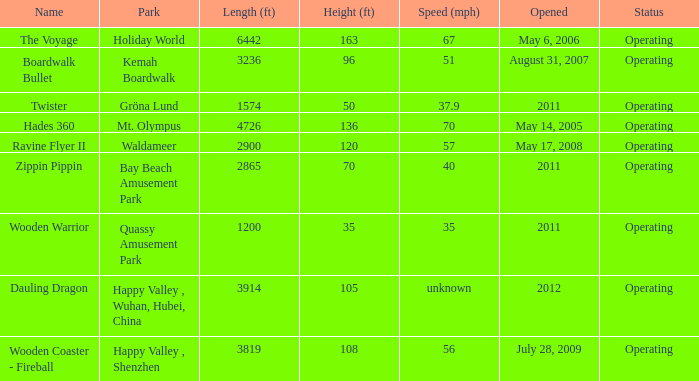How many parks is Zippin Pippin located in 1.0. Give me the full table as a dictionary. {'header': ['Name', 'Park', 'Length (ft)', 'Height (ft)', 'Speed (mph)', 'Opened', 'Status'], 'rows': [['The Voyage', 'Holiday World', '6442', '163', '67', 'May 6, 2006', 'Operating'], ['Boardwalk Bullet', 'Kemah Boardwalk', '3236', '96', '51', 'August 31, 2007', 'Operating'], ['Twister', 'Gröna Lund', '1574', '50', '37.9', '2011', 'Operating'], ['Hades 360', 'Mt. Olympus', '4726', '136', '70', 'May 14, 2005', 'Operating'], ['Ravine Flyer II', 'Waldameer', '2900', '120', '57', 'May 17, 2008', 'Operating'], ['Zippin Pippin', 'Bay Beach Amusement Park', '2865', '70', '40', '2011', 'Operating'], ['Wooden Warrior', 'Quassy Amusement Park', '1200', '35', '35', '2011', 'Operating'], ['Dauling Dragon', 'Happy Valley , Wuhan, Hubei, China', '3914', '105', 'unknown', '2012', 'Operating'], ['Wooden Coaster - Fireball', 'Happy Valley , Shenzhen', '3819', '108', '56', 'July 28, 2009', 'Operating']]} 